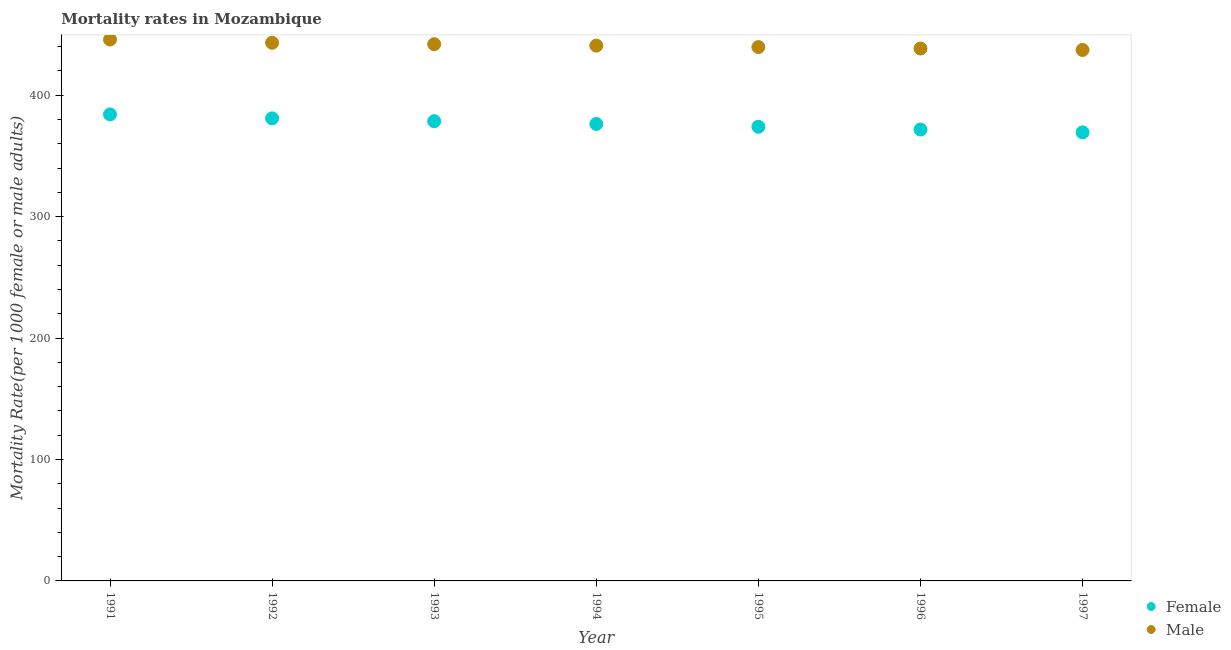What is the male mortality rate in 1995?
Your answer should be very brief. 439.57. Across all years, what is the maximum female mortality rate?
Your answer should be very brief. 384.12. Across all years, what is the minimum female mortality rate?
Offer a very short reply. 369.36. What is the total male mortality rate in the graph?
Keep it short and to the point. 3086.79. What is the difference between the male mortality rate in 1995 and that in 1997?
Your answer should be very brief. 2.37. What is the difference between the female mortality rate in 1993 and the male mortality rate in 1992?
Make the answer very short. -64.56. What is the average female mortality rate per year?
Your answer should be compact. 376.4. In the year 1995, what is the difference between the male mortality rate and female mortality rate?
Keep it short and to the point. 65.61. In how many years, is the female mortality rate greater than 380?
Provide a short and direct response. 2. What is the ratio of the male mortality rate in 1994 to that in 1997?
Make the answer very short. 1.01. Is the difference between the female mortality rate in 1991 and 1997 greater than the difference between the male mortality rate in 1991 and 1997?
Provide a succinct answer. Yes. What is the difference between the highest and the second highest female mortality rate?
Offer a terse response. 3.25. What is the difference between the highest and the lowest male mortality rate?
Offer a very short reply. 8.6. Does the female mortality rate monotonically increase over the years?
Offer a terse response. No. Is the male mortality rate strictly less than the female mortality rate over the years?
Your response must be concise. No. How many legend labels are there?
Offer a terse response. 2. What is the title of the graph?
Keep it short and to the point. Mortality rates in Mozambique. Does "Register a property" appear as one of the legend labels in the graph?
Your answer should be compact. No. What is the label or title of the Y-axis?
Give a very brief answer. Mortality Rate(per 1000 female or male adults). What is the Mortality Rate(per 1000 female or male adults) in Female in 1991?
Offer a very short reply. 384.12. What is the Mortality Rate(per 1000 female or male adults) in Male in 1991?
Keep it short and to the point. 445.8. What is the Mortality Rate(per 1000 female or male adults) of Female in 1992?
Offer a very short reply. 380.87. What is the Mortality Rate(per 1000 female or male adults) of Male in 1992?
Keep it short and to the point. 443.13. What is the Mortality Rate(per 1000 female or male adults) in Female in 1993?
Your answer should be very brief. 378.57. What is the Mortality Rate(per 1000 female or male adults) of Male in 1993?
Ensure brevity in your answer.  441.94. What is the Mortality Rate(per 1000 female or male adults) of Female in 1994?
Keep it short and to the point. 376.27. What is the Mortality Rate(per 1000 female or male adults) in Male in 1994?
Give a very brief answer. 440.76. What is the Mortality Rate(per 1000 female or male adults) of Female in 1995?
Your answer should be compact. 373.96. What is the Mortality Rate(per 1000 female or male adults) of Male in 1995?
Provide a short and direct response. 439.57. What is the Mortality Rate(per 1000 female or male adults) in Female in 1996?
Your answer should be compact. 371.66. What is the Mortality Rate(per 1000 female or male adults) in Male in 1996?
Provide a short and direct response. 438.38. What is the Mortality Rate(per 1000 female or male adults) in Female in 1997?
Make the answer very short. 369.36. What is the Mortality Rate(per 1000 female or male adults) in Male in 1997?
Your answer should be very brief. 437.2. Across all years, what is the maximum Mortality Rate(per 1000 female or male adults) of Female?
Make the answer very short. 384.12. Across all years, what is the maximum Mortality Rate(per 1000 female or male adults) in Male?
Ensure brevity in your answer.  445.8. Across all years, what is the minimum Mortality Rate(per 1000 female or male adults) of Female?
Provide a short and direct response. 369.36. Across all years, what is the minimum Mortality Rate(per 1000 female or male adults) of Male?
Your answer should be very brief. 437.2. What is the total Mortality Rate(per 1000 female or male adults) in Female in the graph?
Provide a short and direct response. 2634.81. What is the total Mortality Rate(per 1000 female or male adults) of Male in the graph?
Provide a short and direct response. 3086.79. What is the difference between the Mortality Rate(per 1000 female or male adults) in Female in 1991 and that in 1992?
Your answer should be compact. 3.25. What is the difference between the Mortality Rate(per 1000 female or male adults) of Male in 1991 and that in 1992?
Your response must be concise. 2.67. What is the difference between the Mortality Rate(per 1000 female or male adults) in Female in 1991 and that in 1993?
Keep it short and to the point. 5.55. What is the difference between the Mortality Rate(per 1000 female or male adults) in Male in 1991 and that in 1993?
Your response must be concise. 3.86. What is the difference between the Mortality Rate(per 1000 female or male adults) in Female in 1991 and that in 1994?
Your answer should be very brief. 7.86. What is the difference between the Mortality Rate(per 1000 female or male adults) of Male in 1991 and that in 1994?
Provide a succinct answer. 5.04. What is the difference between the Mortality Rate(per 1000 female or male adults) in Female in 1991 and that in 1995?
Provide a short and direct response. 10.16. What is the difference between the Mortality Rate(per 1000 female or male adults) in Male in 1991 and that in 1995?
Your response must be concise. 6.23. What is the difference between the Mortality Rate(per 1000 female or male adults) in Female in 1991 and that in 1996?
Your response must be concise. 12.46. What is the difference between the Mortality Rate(per 1000 female or male adults) of Male in 1991 and that in 1996?
Give a very brief answer. 7.42. What is the difference between the Mortality Rate(per 1000 female or male adults) of Female in 1991 and that in 1997?
Offer a terse response. 14.76. What is the difference between the Mortality Rate(per 1000 female or male adults) of Male in 1991 and that in 1997?
Provide a short and direct response. 8.6. What is the difference between the Mortality Rate(per 1000 female or male adults) of Female in 1992 and that in 1993?
Provide a succinct answer. 2.3. What is the difference between the Mortality Rate(per 1000 female or male adults) of Male in 1992 and that in 1993?
Ensure brevity in your answer.  1.19. What is the difference between the Mortality Rate(per 1000 female or male adults) in Female in 1992 and that in 1994?
Give a very brief answer. 4.6. What is the difference between the Mortality Rate(per 1000 female or male adults) in Male in 1992 and that in 1994?
Provide a short and direct response. 2.37. What is the difference between the Mortality Rate(per 1000 female or male adults) in Female in 1992 and that in 1995?
Your response must be concise. 6.91. What is the difference between the Mortality Rate(per 1000 female or male adults) of Male in 1992 and that in 1995?
Provide a short and direct response. 3.56. What is the difference between the Mortality Rate(per 1000 female or male adults) of Female in 1992 and that in 1996?
Give a very brief answer. 9.21. What is the difference between the Mortality Rate(per 1000 female or male adults) in Male in 1992 and that in 1996?
Provide a short and direct response. 4.75. What is the difference between the Mortality Rate(per 1000 female or male adults) in Female in 1992 and that in 1997?
Provide a short and direct response. 11.51. What is the difference between the Mortality Rate(per 1000 female or male adults) in Male in 1992 and that in 1997?
Provide a short and direct response. 5.93. What is the difference between the Mortality Rate(per 1000 female or male adults) of Female in 1993 and that in 1994?
Offer a terse response. 2.3. What is the difference between the Mortality Rate(per 1000 female or male adults) of Male in 1993 and that in 1994?
Keep it short and to the point. 1.19. What is the difference between the Mortality Rate(per 1000 female or male adults) of Female in 1993 and that in 1995?
Provide a short and direct response. 4.6. What is the difference between the Mortality Rate(per 1000 female or male adults) in Male in 1993 and that in 1995?
Your response must be concise. 2.37. What is the difference between the Mortality Rate(per 1000 female or male adults) of Female in 1993 and that in 1996?
Keep it short and to the point. 6.91. What is the difference between the Mortality Rate(per 1000 female or male adults) in Male in 1993 and that in 1996?
Make the answer very short. 3.56. What is the difference between the Mortality Rate(per 1000 female or male adults) in Female in 1993 and that in 1997?
Provide a succinct answer. 9.21. What is the difference between the Mortality Rate(per 1000 female or male adults) in Male in 1993 and that in 1997?
Your response must be concise. 4.75. What is the difference between the Mortality Rate(per 1000 female or male adults) of Female in 1994 and that in 1995?
Offer a terse response. 2.3. What is the difference between the Mortality Rate(per 1000 female or male adults) in Male in 1994 and that in 1995?
Make the answer very short. 1.19. What is the difference between the Mortality Rate(per 1000 female or male adults) of Female in 1994 and that in 1996?
Give a very brief answer. 4.6. What is the difference between the Mortality Rate(per 1000 female or male adults) of Male in 1994 and that in 1996?
Your answer should be very brief. 2.37. What is the difference between the Mortality Rate(per 1000 female or male adults) of Female in 1994 and that in 1997?
Provide a short and direct response. 6.91. What is the difference between the Mortality Rate(per 1000 female or male adults) in Male in 1994 and that in 1997?
Make the answer very short. 3.56. What is the difference between the Mortality Rate(per 1000 female or male adults) in Female in 1995 and that in 1996?
Offer a terse response. 2.3. What is the difference between the Mortality Rate(per 1000 female or male adults) in Male in 1995 and that in 1996?
Provide a short and direct response. 1.19. What is the difference between the Mortality Rate(per 1000 female or male adults) in Female in 1995 and that in 1997?
Provide a short and direct response. 4.6. What is the difference between the Mortality Rate(per 1000 female or male adults) in Male in 1995 and that in 1997?
Offer a terse response. 2.37. What is the difference between the Mortality Rate(per 1000 female or male adults) in Female in 1996 and that in 1997?
Your answer should be very brief. 2.3. What is the difference between the Mortality Rate(per 1000 female or male adults) in Male in 1996 and that in 1997?
Offer a very short reply. 1.19. What is the difference between the Mortality Rate(per 1000 female or male adults) in Female in 1991 and the Mortality Rate(per 1000 female or male adults) in Male in 1992?
Provide a succinct answer. -59.01. What is the difference between the Mortality Rate(per 1000 female or male adults) of Female in 1991 and the Mortality Rate(per 1000 female or male adults) of Male in 1993?
Provide a succinct answer. -57.82. What is the difference between the Mortality Rate(per 1000 female or male adults) of Female in 1991 and the Mortality Rate(per 1000 female or male adults) of Male in 1994?
Your answer should be very brief. -56.63. What is the difference between the Mortality Rate(per 1000 female or male adults) in Female in 1991 and the Mortality Rate(per 1000 female or male adults) in Male in 1995?
Ensure brevity in your answer.  -55.45. What is the difference between the Mortality Rate(per 1000 female or male adults) in Female in 1991 and the Mortality Rate(per 1000 female or male adults) in Male in 1996?
Give a very brief answer. -54.26. What is the difference between the Mortality Rate(per 1000 female or male adults) of Female in 1991 and the Mortality Rate(per 1000 female or male adults) of Male in 1997?
Your answer should be compact. -53.08. What is the difference between the Mortality Rate(per 1000 female or male adults) in Female in 1992 and the Mortality Rate(per 1000 female or male adults) in Male in 1993?
Provide a succinct answer. -61.07. What is the difference between the Mortality Rate(per 1000 female or male adults) in Female in 1992 and the Mortality Rate(per 1000 female or male adults) in Male in 1994?
Offer a very short reply. -59.89. What is the difference between the Mortality Rate(per 1000 female or male adults) in Female in 1992 and the Mortality Rate(per 1000 female or male adults) in Male in 1995?
Ensure brevity in your answer.  -58.7. What is the difference between the Mortality Rate(per 1000 female or male adults) in Female in 1992 and the Mortality Rate(per 1000 female or male adults) in Male in 1996?
Provide a succinct answer. -57.52. What is the difference between the Mortality Rate(per 1000 female or male adults) of Female in 1992 and the Mortality Rate(per 1000 female or male adults) of Male in 1997?
Give a very brief answer. -56.33. What is the difference between the Mortality Rate(per 1000 female or male adults) in Female in 1993 and the Mortality Rate(per 1000 female or male adults) in Male in 1994?
Your response must be concise. -62.19. What is the difference between the Mortality Rate(per 1000 female or male adults) of Female in 1993 and the Mortality Rate(per 1000 female or male adults) of Male in 1995?
Provide a succinct answer. -61. What is the difference between the Mortality Rate(per 1000 female or male adults) in Female in 1993 and the Mortality Rate(per 1000 female or male adults) in Male in 1996?
Provide a short and direct response. -59.82. What is the difference between the Mortality Rate(per 1000 female or male adults) in Female in 1993 and the Mortality Rate(per 1000 female or male adults) in Male in 1997?
Make the answer very short. -58.63. What is the difference between the Mortality Rate(per 1000 female or male adults) of Female in 1994 and the Mortality Rate(per 1000 female or male adults) of Male in 1995?
Your answer should be very brief. -63.31. What is the difference between the Mortality Rate(per 1000 female or male adults) in Female in 1994 and the Mortality Rate(per 1000 female or male adults) in Male in 1996?
Provide a succinct answer. -62.12. What is the difference between the Mortality Rate(per 1000 female or male adults) in Female in 1994 and the Mortality Rate(per 1000 female or male adults) in Male in 1997?
Your response must be concise. -60.93. What is the difference between the Mortality Rate(per 1000 female or male adults) of Female in 1995 and the Mortality Rate(per 1000 female or male adults) of Male in 1996?
Provide a short and direct response. -64.42. What is the difference between the Mortality Rate(per 1000 female or male adults) of Female in 1995 and the Mortality Rate(per 1000 female or male adults) of Male in 1997?
Your answer should be compact. -63.23. What is the difference between the Mortality Rate(per 1000 female or male adults) in Female in 1996 and the Mortality Rate(per 1000 female or male adults) in Male in 1997?
Your answer should be very brief. -65.54. What is the average Mortality Rate(per 1000 female or male adults) in Female per year?
Give a very brief answer. 376.4. What is the average Mortality Rate(per 1000 female or male adults) of Male per year?
Provide a succinct answer. 440.97. In the year 1991, what is the difference between the Mortality Rate(per 1000 female or male adults) in Female and Mortality Rate(per 1000 female or male adults) in Male?
Ensure brevity in your answer.  -61.68. In the year 1992, what is the difference between the Mortality Rate(per 1000 female or male adults) of Female and Mortality Rate(per 1000 female or male adults) of Male?
Offer a terse response. -62.26. In the year 1993, what is the difference between the Mortality Rate(per 1000 female or male adults) of Female and Mortality Rate(per 1000 female or male adults) of Male?
Give a very brief answer. -63.38. In the year 1994, what is the difference between the Mortality Rate(per 1000 female or male adults) in Female and Mortality Rate(per 1000 female or male adults) in Male?
Provide a succinct answer. -64.49. In the year 1995, what is the difference between the Mortality Rate(per 1000 female or male adults) of Female and Mortality Rate(per 1000 female or male adults) of Male?
Give a very brief answer. -65.61. In the year 1996, what is the difference between the Mortality Rate(per 1000 female or male adults) of Female and Mortality Rate(per 1000 female or male adults) of Male?
Your answer should be very brief. -66.72. In the year 1997, what is the difference between the Mortality Rate(per 1000 female or male adults) of Female and Mortality Rate(per 1000 female or male adults) of Male?
Your answer should be compact. -67.84. What is the ratio of the Mortality Rate(per 1000 female or male adults) of Female in 1991 to that in 1992?
Provide a succinct answer. 1.01. What is the ratio of the Mortality Rate(per 1000 female or male adults) of Male in 1991 to that in 1992?
Your answer should be very brief. 1.01. What is the ratio of the Mortality Rate(per 1000 female or male adults) in Female in 1991 to that in 1993?
Your answer should be very brief. 1.01. What is the ratio of the Mortality Rate(per 1000 female or male adults) of Male in 1991 to that in 1993?
Give a very brief answer. 1.01. What is the ratio of the Mortality Rate(per 1000 female or male adults) of Female in 1991 to that in 1994?
Keep it short and to the point. 1.02. What is the ratio of the Mortality Rate(per 1000 female or male adults) of Male in 1991 to that in 1994?
Offer a terse response. 1.01. What is the ratio of the Mortality Rate(per 1000 female or male adults) in Female in 1991 to that in 1995?
Provide a short and direct response. 1.03. What is the ratio of the Mortality Rate(per 1000 female or male adults) in Male in 1991 to that in 1995?
Offer a terse response. 1.01. What is the ratio of the Mortality Rate(per 1000 female or male adults) in Female in 1991 to that in 1996?
Your answer should be very brief. 1.03. What is the ratio of the Mortality Rate(per 1000 female or male adults) of Male in 1991 to that in 1996?
Keep it short and to the point. 1.02. What is the ratio of the Mortality Rate(per 1000 female or male adults) in Female in 1991 to that in 1997?
Offer a terse response. 1.04. What is the ratio of the Mortality Rate(per 1000 female or male adults) in Male in 1991 to that in 1997?
Offer a very short reply. 1.02. What is the ratio of the Mortality Rate(per 1000 female or male adults) in Female in 1992 to that in 1993?
Keep it short and to the point. 1.01. What is the ratio of the Mortality Rate(per 1000 female or male adults) of Female in 1992 to that in 1994?
Your answer should be compact. 1.01. What is the ratio of the Mortality Rate(per 1000 female or male adults) of Male in 1992 to that in 1994?
Ensure brevity in your answer.  1.01. What is the ratio of the Mortality Rate(per 1000 female or male adults) of Female in 1992 to that in 1995?
Offer a very short reply. 1.02. What is the ratio of the Mortality Rate(per 1000 female or male adults) of Female in 1992 to that in 1996?
Provide a succinct answer. 1.02. What is the ratio of the Mortality Rate(per 1000 female or male adults) in Male in 1992 to that in 1996?
Keep it short and to the point. 1.01. What is the ratio of the Mortality Rate(per 1000 female or male adults) in Female in 1992 to that in 1997?
Your answer should be compact. 1.03. What is the ratio of the Mortality Rate(per 1000 female or male adults) of Male in 1992 to that in 1997?
Keep it short and to the point. 1.01. What is the ratio of the Mortality Rate(per 1000 female or male adults) of Female in 1993 to that in 1995?
Your answer should be compact. 1.01. What is the ratio of the Mortality Rate(per 1000 female or male adults) of Male in 1993 to that in 1995?
Keep it short and to the point. 1.01. What is the ratio of the Mortality Rate(per 1000 female or male adults) in Female in 1993 to that in 1996?
Give a very brief answer. 1.02. What is the ratio of the Mortality Rate(per 1000 female or male adults) in Male in 1993 to that in 1996?
Offer a very short reply. 1.01. What is the ratio of the Mortality Rate(per 1000 female or male adults) in Female in 1993 to that in 1997?
Provide a succinct answer. 1.02. What is the ratio of the Mortality Rate(per 1000 female or male adults) in Male in 1993 to that in 1997?
Your response must be concise. 1.01. What is the ratio of the Mortality Rate(per 1000 female or male adults) in Male in 1994 to that in 1995?
Ensure brevity in your answer.  1. What is the ratio of the Mortality Rate(per 1000 female or male adults) of Female in 1994 to that in 1996?
Make the answer very short. 1.01. What is the ratio of the Mortality Rate(per 1000 female or male adults) in Male in 1994 to that in 1996?
Give a very brief answer. 1.01. What is the ratio of the Mortality Rate(per 1000 female or male adults) in Female in 1994 to that in 1997?
Offer a terse response. 1.02. What is the ratio of the Mortality Rate(per 1000 female or male adults) of Male in 1994 to that in 1997?
Provide a short and direct response. 1.01. What is the ratio of the Mortality Rate(per 1000 female or male adults) of Female in 1995 to that in 1997?
Ensure brevity in your answer.  1.01. What is the ratio of the Mortality Rate(per 1000 female or male adults) in Male in 1995 to that in 1997?
Make the answer very short. 1.01. What is the ratio of the Mortality Rate(per 1000 female or male adults) in Male in 1996 to that in 1997?
Your response must be concise. 1. What is the difference between the highest and the second highest Mortality Rate(per 1000 female or male adults) of Female?
Give a very brief answer. 3.25. What is the difference between the highest and the second highest Mortality Rate(per 1000 female or male adults) of Male?
Your response must be concise. 2.67. What is the difference between the highest and the lowest Mortality Rate(per 1000 female or male adults) in Female?
Give a very brief answer. 14.76. What is the difference between the highest and the lowest Mortality Rate(per 1000 female or male adults) of Male?
Offer a very short reply. 8.6. 